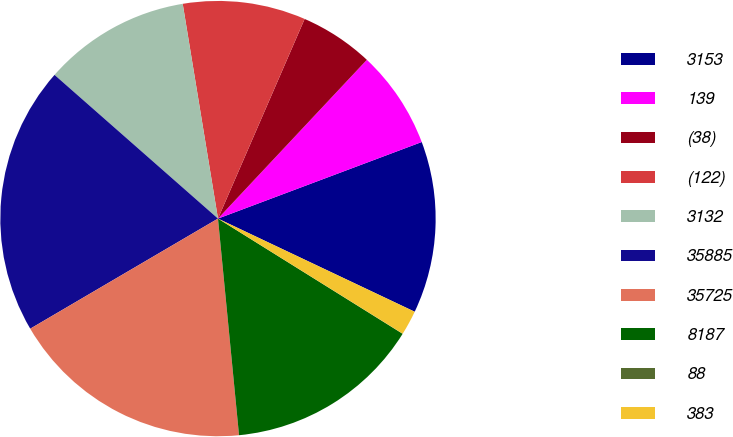<chart> <loc_0><loc_0><loc_500><loc_500><pie_chart><fcel>3153<fcel>139<fcel>(38)<fcel>(122)<fcel>3132<fcel>35885<fcel>35725<fcel>8187<fcel>88<fcel>383<nl><fcel>12.76%<fcel>7.29%<fcel>5.47%<fcel>9.11%<fcel>10.93%<fcel>19.92%<fcel>18.1%<fcel>14.58%<fcel>0.01%<fcel>1.83%<nl></chart> 